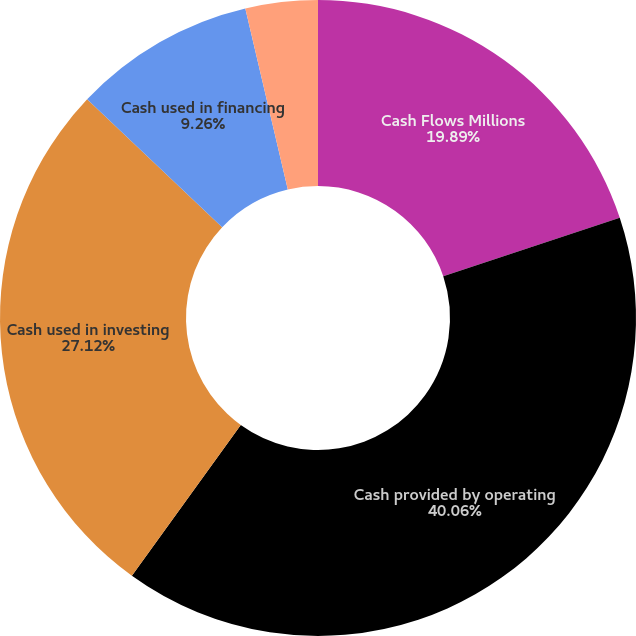Convert chart to OTSL. <chart><loc_0><loc_0><loc_500><loc_500><pie_chart><fcel>Cash Flows Millions<fcel>Cash provided by operating<fcel>Cash used in investing<fcel>Cash used in financing<fcel>Net change in cash and cash<nl><fcel>19.89%<fcel>40.06%<fcel>27.12%<fcel>9.26%<fcel>3.67%<nl></chart> 